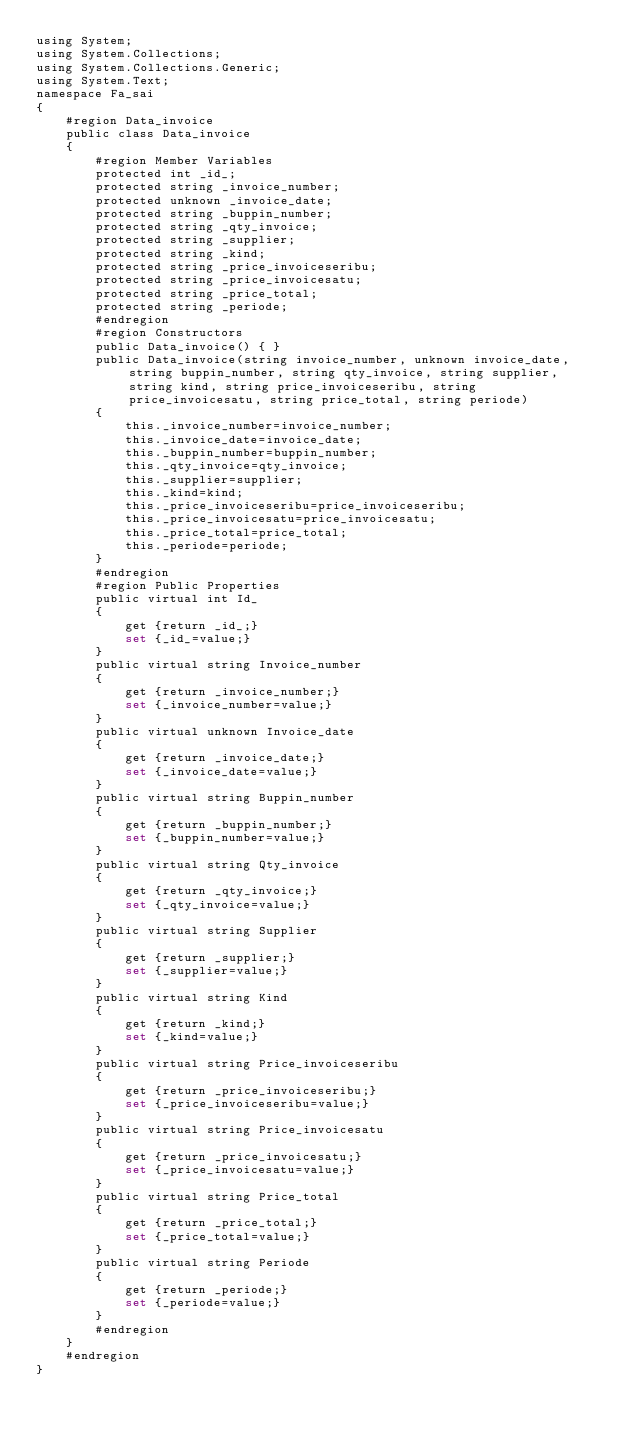Convert code to text. <code><loc_0><loc_0><loc_500><loc_500><_SQL_>using System;
using System.Collections;
using System.Collections.Generic;
using System.Text;
namespace Fa_sai
{
    #region Data_invoice
    public class Data_invoice
    {
        #region Member Variables
        protected int _id_;
        protected string _invoice_number;
        protected unknown _invoice_date;
        protected string _buppin_number;
        protected string _qty_invoice;
        protected string _supplier;
        protected string _kind;
        protected string _price_invoiceseribu;
        protected string _price_invoicesatu;
        protected string _price_total;
        protected string _periode;
        #endregion
        #region Constructors
        public Data_invoice() { }
        public Data_invoice(string invoice_number, unknown invoice_date, string buppin_number, string qty_invoice, string supplier, string kind, string price_invoiceseribu, string price_invoicesatu, string price_total, string periode)
        {
            this._invoice_number=invoice_number;
            this._invoice_date=invoice_date;
            this._buppin_number=buppin_number;
            this._qty_invoice=qty_invoice;
            this._supplier=supplier;
            this._kind=kind;
            this._price_invoiceseribu=price_invoiceseribu;
            this._price_invoicesatu=price_invoicesatu;
            this._price_total=price_total;
            this._periode=periode;
        }
        #endregion
        #region Public Properties
        public virtual int Id_
        {
            get {return _id_;}
            set {_id_=value;}
        }
        public virtual string Invoice_number
        {
            get {return _invoice_number;}
            set {_invoice_number=value;}
        }
        public virtual unknown Invoice_date
        {
            get {return _invoice_date;}
            set {_invoice_date=value;}
        }
        public virtual string Buppin_number
        {
            get {return _buppin_number;}
            set {_buppin_number=value;}
        }
        public virtual string Qty_invoice
        {
            get {return _qty_invoice;}
            set {_qty_invoice=value;}
        }
        public virtual string Supplier
        {
            get {return _supplier;}
            set {_supplier=value;}
        }
        public virtual string Kind
        {
            get {return _kind;}
            set {_kind=value;}
        }
        public virtual string Price_invoiceseribu
        {
            get {return _price_invoiceseribu;}
            set {_price_invoiceseribu=value;}
        }
        public virtual string Price_invoicesatu
        {
            get {return _price_invoicesatu;}
            set {_price_invoicesatu=value;}
        }
        public virtual string Price_total
        {
            get {return _price_total;}
            set {_price_total=value;}
        }
        public virtual string Periode
        {
            get {return _periode;}
            set {_periode=value;}
        }
        #endregion
    }
    #endregion
}</code> 